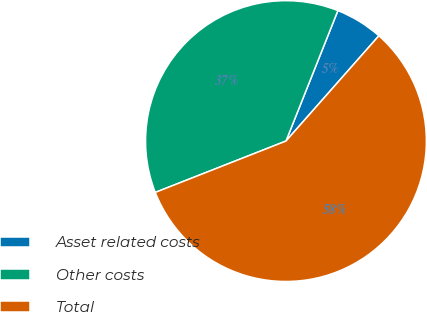Convert chart to OTSL. <chart><loc_0><loc_0><loc_500><loc_500><pie_chart><fcel>Asset related costs<fcel>Other costs<fcel>Total<nl><fcel>5.48%<fcel>36.99%<fcel>57.53%<nl></chart> 